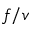Convert formula to latex. <formula><loc_0><loc_0><loc_500><loc_500>f / v</formula> 